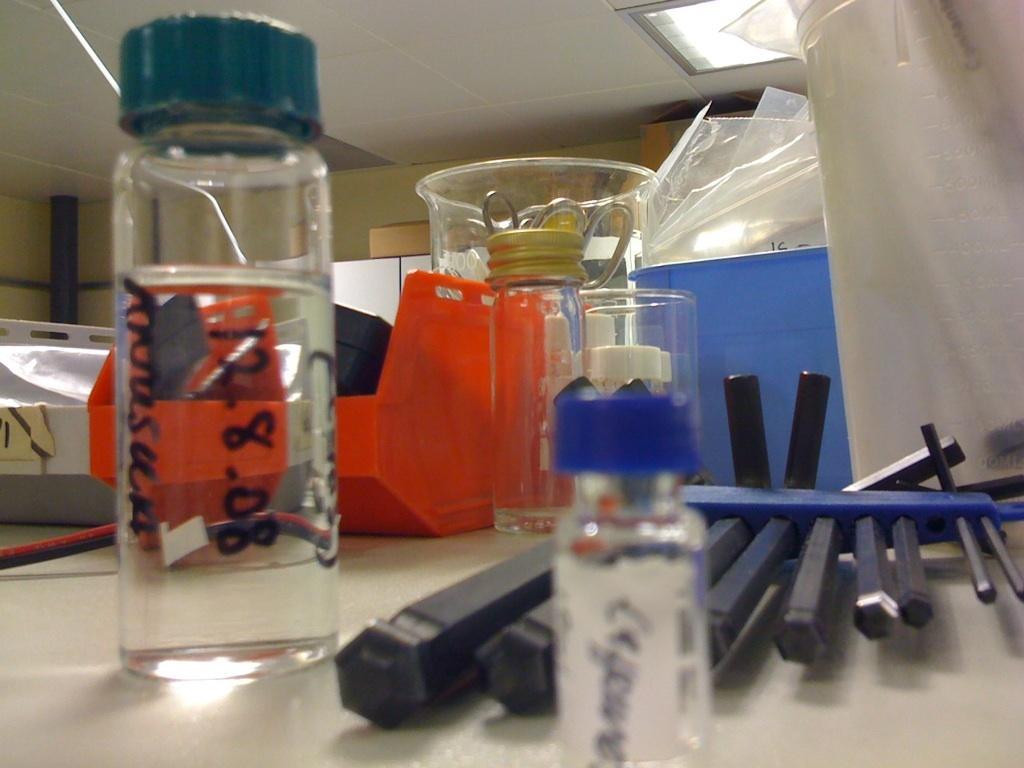Can you describe this image briefly? In this image we can see a bottle, jar, scissors, covers and tubes placed on the table. This is the ceiling. 